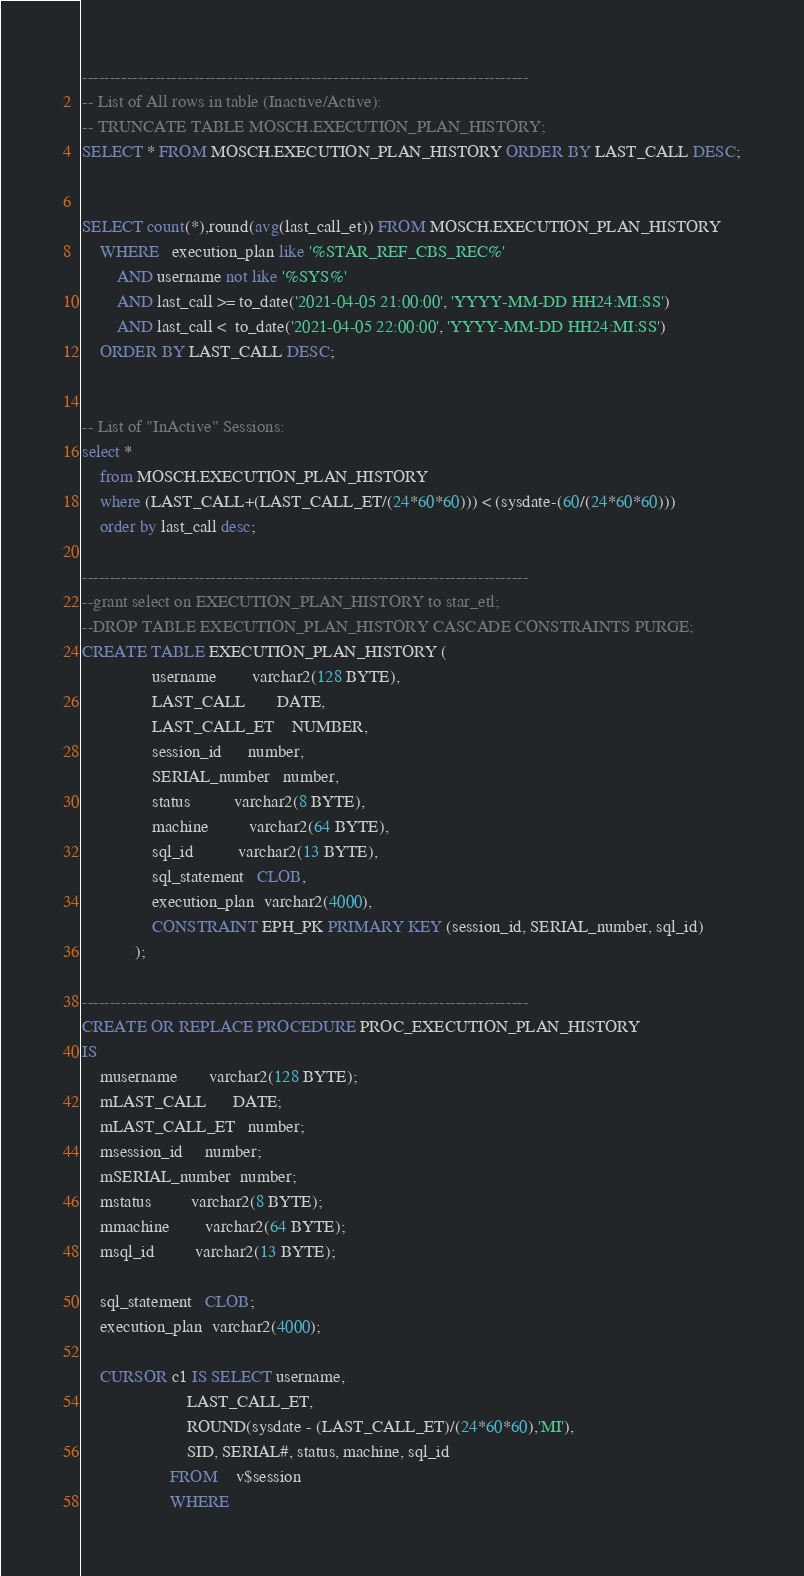Convert code to text. <code><loc_0><loc_0><loc_500><loc_500><_SQL_>--------------------------------------------------------------------------------
-- List of All rows in table (Inactive/Active):
-- TRUNCATE TABLE MOSCH.EXECUTION_PLAN_HISTORY;
SELECT * FROM MOSCH.EXECUTION_PLAN_HISTORY ORDER BY LAST_CALL DESC;


SELECT count(*),round(avg(last_call_et)) FROM MOSCH.EXECUTION_PLAN_HISTORY 
    WHERE   execution_plan like '%STAR_REF_CBS_REC%'
        AND username not like '%SYS%'
        AND last_call >= to_date('2021-04-05 21:00:00', 'YYYY-MM-DD HH24:MI:SS')
        AND last_call <  to_date('2021-04-05 22:00:00', 'YYYY-MM-DD HH24:MI:SS')
    ORDER BY LAST_CALL DESC;


-- List of "InActive" Sessions:
select * 
    from MOSCH.EXECUTION_PLAN_HISTORY 
    where (LAST_CALL+(LAST_CALL_ET/(24*60*60))) < (sysdate-(60/(24*60*60))) 
    order by last_call desc;

--------------------------------------------------------------------------------
--grant select on EXECUTION_PLAN_HISTORY to star_etl;
--DROP TABLE EXECUTION_PLAN_HISTORY CASCADE CONSTRAINTS PURGE;
CREATE TABLE EXECUTION_PLAN_HISTORY (
                username        varchar2(128 BYTE), 
                LAST_CALL       DATE,
                LAST_CALL_ET    NUMBER,
                session_id      number, 
                SERIAL_number   number, 
                status          varchar2(8 BYTE), 
                machine         varchar2(64 BYTE), 
                sql_id          varchar2(13 BYTE), 
                sql_statement   CLOB, 
                execution_plan  varchar2(4000), 
                CONSTRAINT EPH_PK PRIMARY KEY (session_id, SERIAL_number, sql_id)
            );

--------------------------------------------------------------------------------
CREATE OR REPLACE PROCEDURE PROC_EXECUTION_PLAN_HISTORY 
IS 
    musername       varchar2(128 BYTE);
    mLAST_CALL      DATE;
    mLAST_CALL_ET   number;
    msession_id     number;
    mSERIAL_number  number;
    mstatus         varchar2(8 BYTE);
    mmachine        varchar2(64 BYTE);
    msql_id         varchar2(13 BYTE);

    sql_statement   CLOB;
    execution_plan  varchar2(4000);

    CURSOR c1 IS SELECT username, 
                        LAST_CALL_ET,
                        ROUND(sysdate - (LAST_CALL_ET)/(24*60*60),'MI'), 
                        SID, SERIAL#, status, machine, sql_id  
                    FROM    v$session 
                    WHERE   </code> 